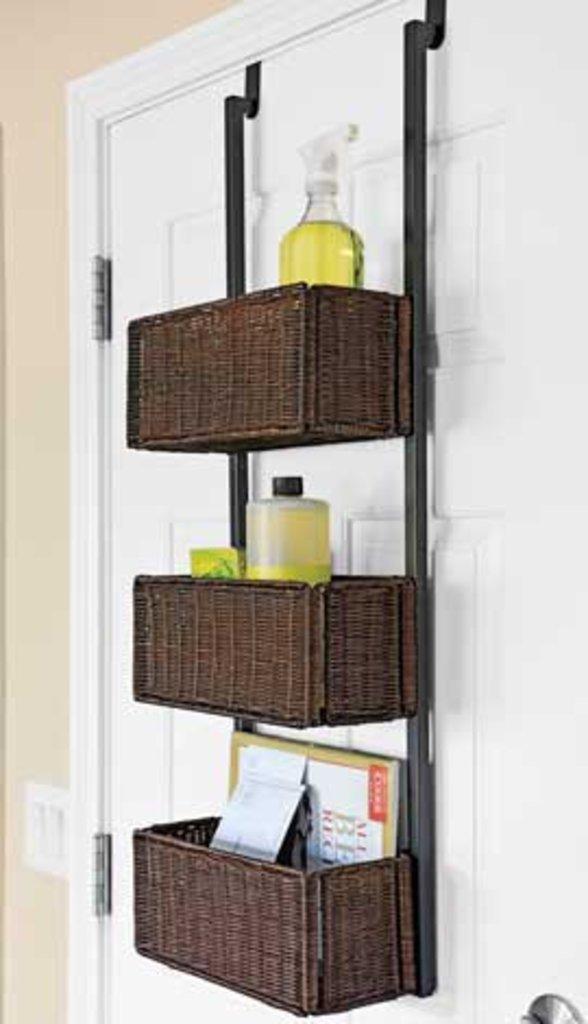Describe this image in one or two sentences. In the foreground I can see a wall, cupboard and a stand in which bottles and books are there. This image is taken may be in a room. 